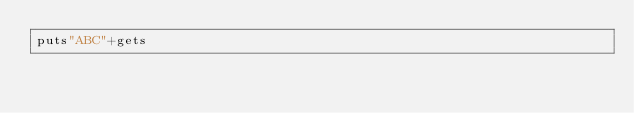<code> <loc_0><loc_0><loc_500><loc_500><_Ruby_>puts"ABC"+gets</code> 